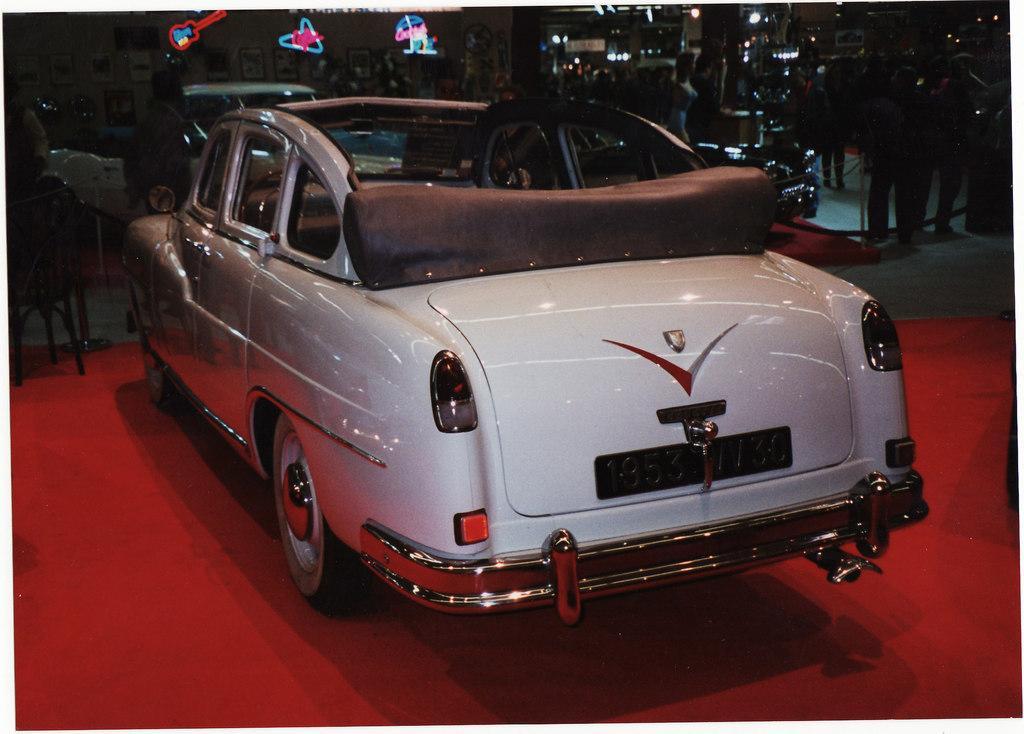How would you summarize this image in a sentence or two? In this picture we can see vehicles, poles and masts on the floor. There are people. In the background of the image we can see frames on the wall, lights and objects. 